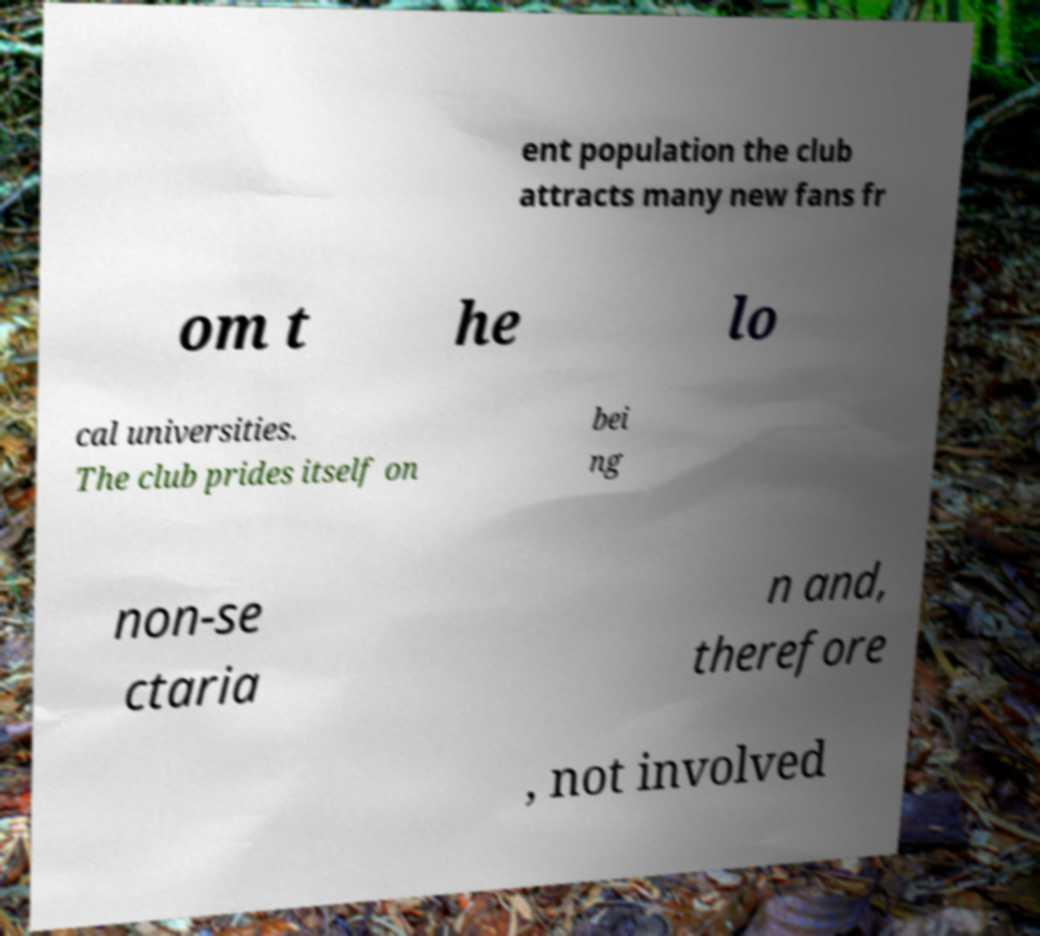Could you assist in decoding the text presented in this image and type it out clearly? ent population the club attracts many new fans fr om t he lo cal universities. The club prides itself on bei ng non-se ctaria n and, therefore , not involved 